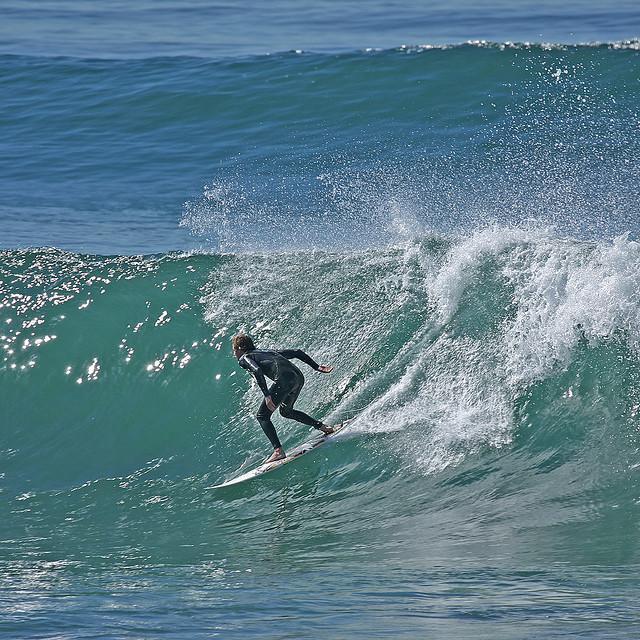How many people are surfing?
Give a very brief answer. 1. 